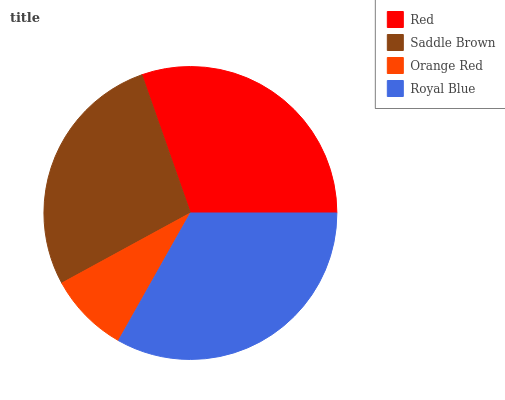Is Orange Red the minimum?
Answer yes or no. Yes. Is Royal Blue the maximum?
Answer yes or no. Yes. Is Saddle Brown the minimum?
Answer yes or no. No. Is Saddle Brown the maximum?
Answer yes or no. No. Is Red greater than Saddle Brown?
Answer yes or no. Yes. Is Saddle Brown less than Red?
Answer yes or no. Yes. Is Saddle Brown greater than Red?
Answer yes or no. No. Is Red less than Saddle Brown?
Answer yes or no. No. Is Red the high median?
Answer yes or no. Yes. Is Saddle Brown the low median?
Answer yes or no. Yes. Is Saddle Brown the high median?
Answer yes or no. No. Is Orange Red the low median?
Answer yes or no. No. 